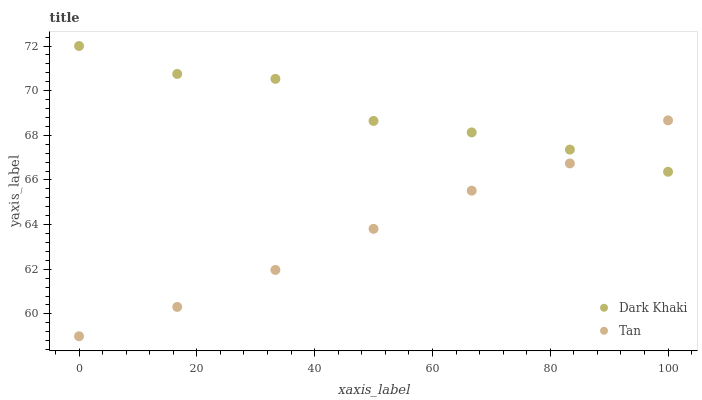Does Tan have the minimum area under the curve?
Answer yes or no. Yes. Does Dark Khaki have the maximum area under the curve?
Answer yes or no. Yes. Does Tan have the maximum area under the curve?
Answer yes or no. No. Is Tan the smoothest?
Answer yes or no. Yes. Is Dark Khaki the roughest?
Answer yes or no. Yes. Is Tan the roughest?
Answer yes or no. No. Does Tan have the lowest value?
Answer yes or no. Yes. Does Dark Khaki have the highest value?
Answer yes or no. Yes. Does Tan have the highest value?
Answer yes or no. No. Does Tan intersect Dark Khaki?
Answer yes or no. Yes. Is Tan less than Dark Khaki?
Answer yes or no. No. Is Tan greater than Dark Khaki?
Answer yes or no. No. 